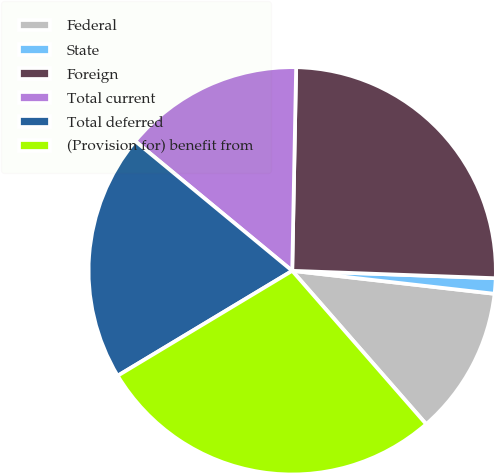<chart> <loc_0><loc_0><loc_500><loc_500><pie_chart><fcel>Federal<fcel>State<fcel>Foreign<fcel>Total current<fcel>Total deferred<fcel>(Provision for) benefit from<nl><fcel>11.77%<fcel>1.22%<fcel>25.27%<fcel>14.32%<fcel>19.6%<fcel>27.81%<nl></chart> 